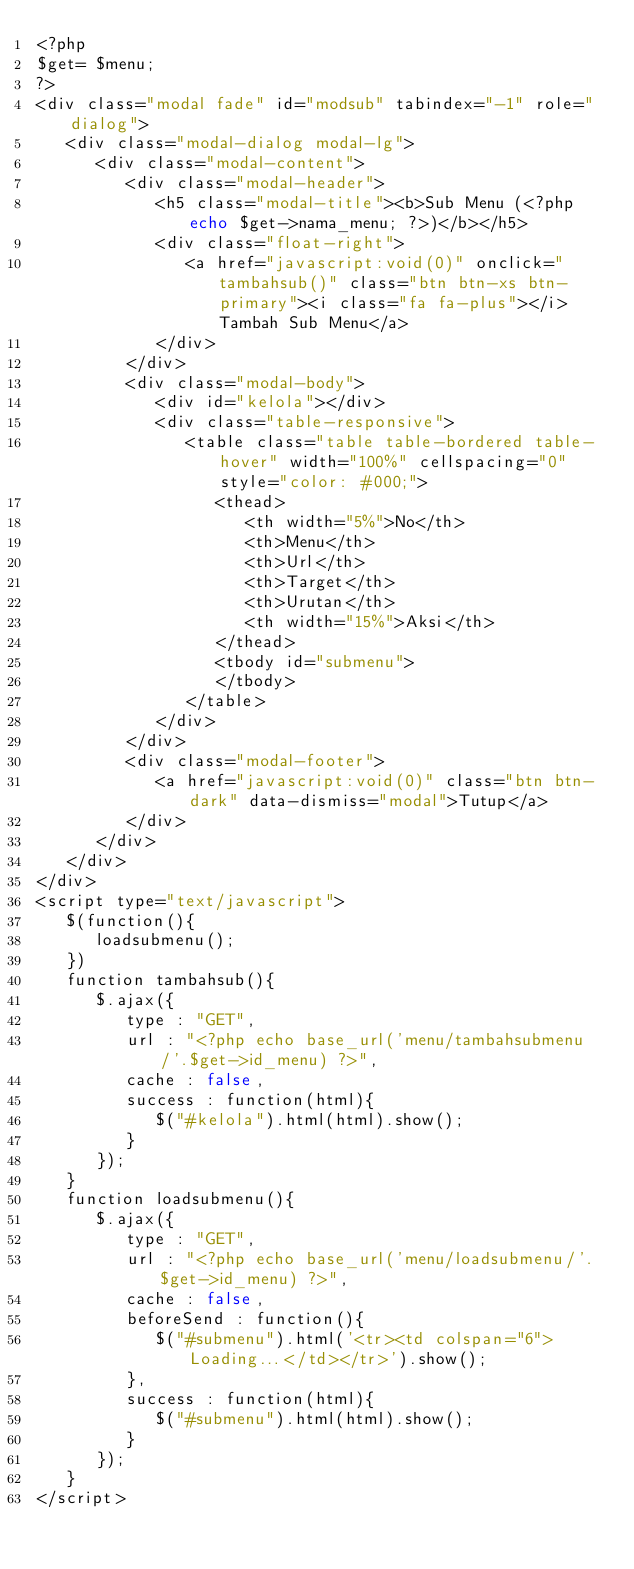Convert code to text. <code><loc_0><loc_0><loc_500><loc_500><_PHP_><?php 
$get= $menu;
?>
<div class="modal fade" id="modsub" tabindex="-1" role="dialog">
   <div class="modal-dialog modal-lg">
      <div class="modal-content">
         <div class="modal-header">
            <h5 class="modal-title"><b>Sub Menu (<?php echo $get->nama_menu; ?>)</b></h5>
            <div class="float-right">
               <a href="javascript:void(0)" onclick="tambahsub()" class="btn btn-xs btn-primary"><i class="fa fa-plus"></i> Tambah Sub Menu</a>
            </div>
         </div>
         <div class="modal-body">
            <div id="kelola"></div>
            <div class="table-responsive">
               <table class="table table-bordered table-hover" width="100%" cellspacing="0" style="color: #000;">
                  <thead>
                     <th width="5%">No</th>
                     <th>Menu</th>
                     <th>Url</th>
                     <th>Target</th>
                     <th>Urutan</th>
                     <th width="15%">Aksi</th>
                  </thead>
                  <tbody id="submenu">
                  </tbody>
               </table>
            </div>
         </div>
         <div class="modal-footer">
            <a href="javascript:void(0)" class="btn btn-dark" data-dismiss="modal">Tutup</a>
         </div>
      </div>
   </div>
</div>
<script type="text/javascript">
   $(function(){
      loadsubmenu();
   })
   function tambahsub(){
      $.ajax({
         type : "GET",
         url : "<?php echo base_url('menu/tambahsubmenu/'.$get->id_menu) ?>",
         cache : false,
         success : function(html){
            $("#kelola").html(html).show();
         }
      });
   }
   function loadsubmenu(){
      $.ajax({
         type : "GET",
         url : "<?php echo base_url('menu/loadsubmenu/'.$get->id_menu) ?>",
         cache : false,
         beforeSend : function(){
            $("#submenu").html('<tr><td colspan="6">Loading...</td></tr>').show();
         },
         success : function(html){
            $("#submenu").html(html).show();
         }
      });
   }
</script></code> 